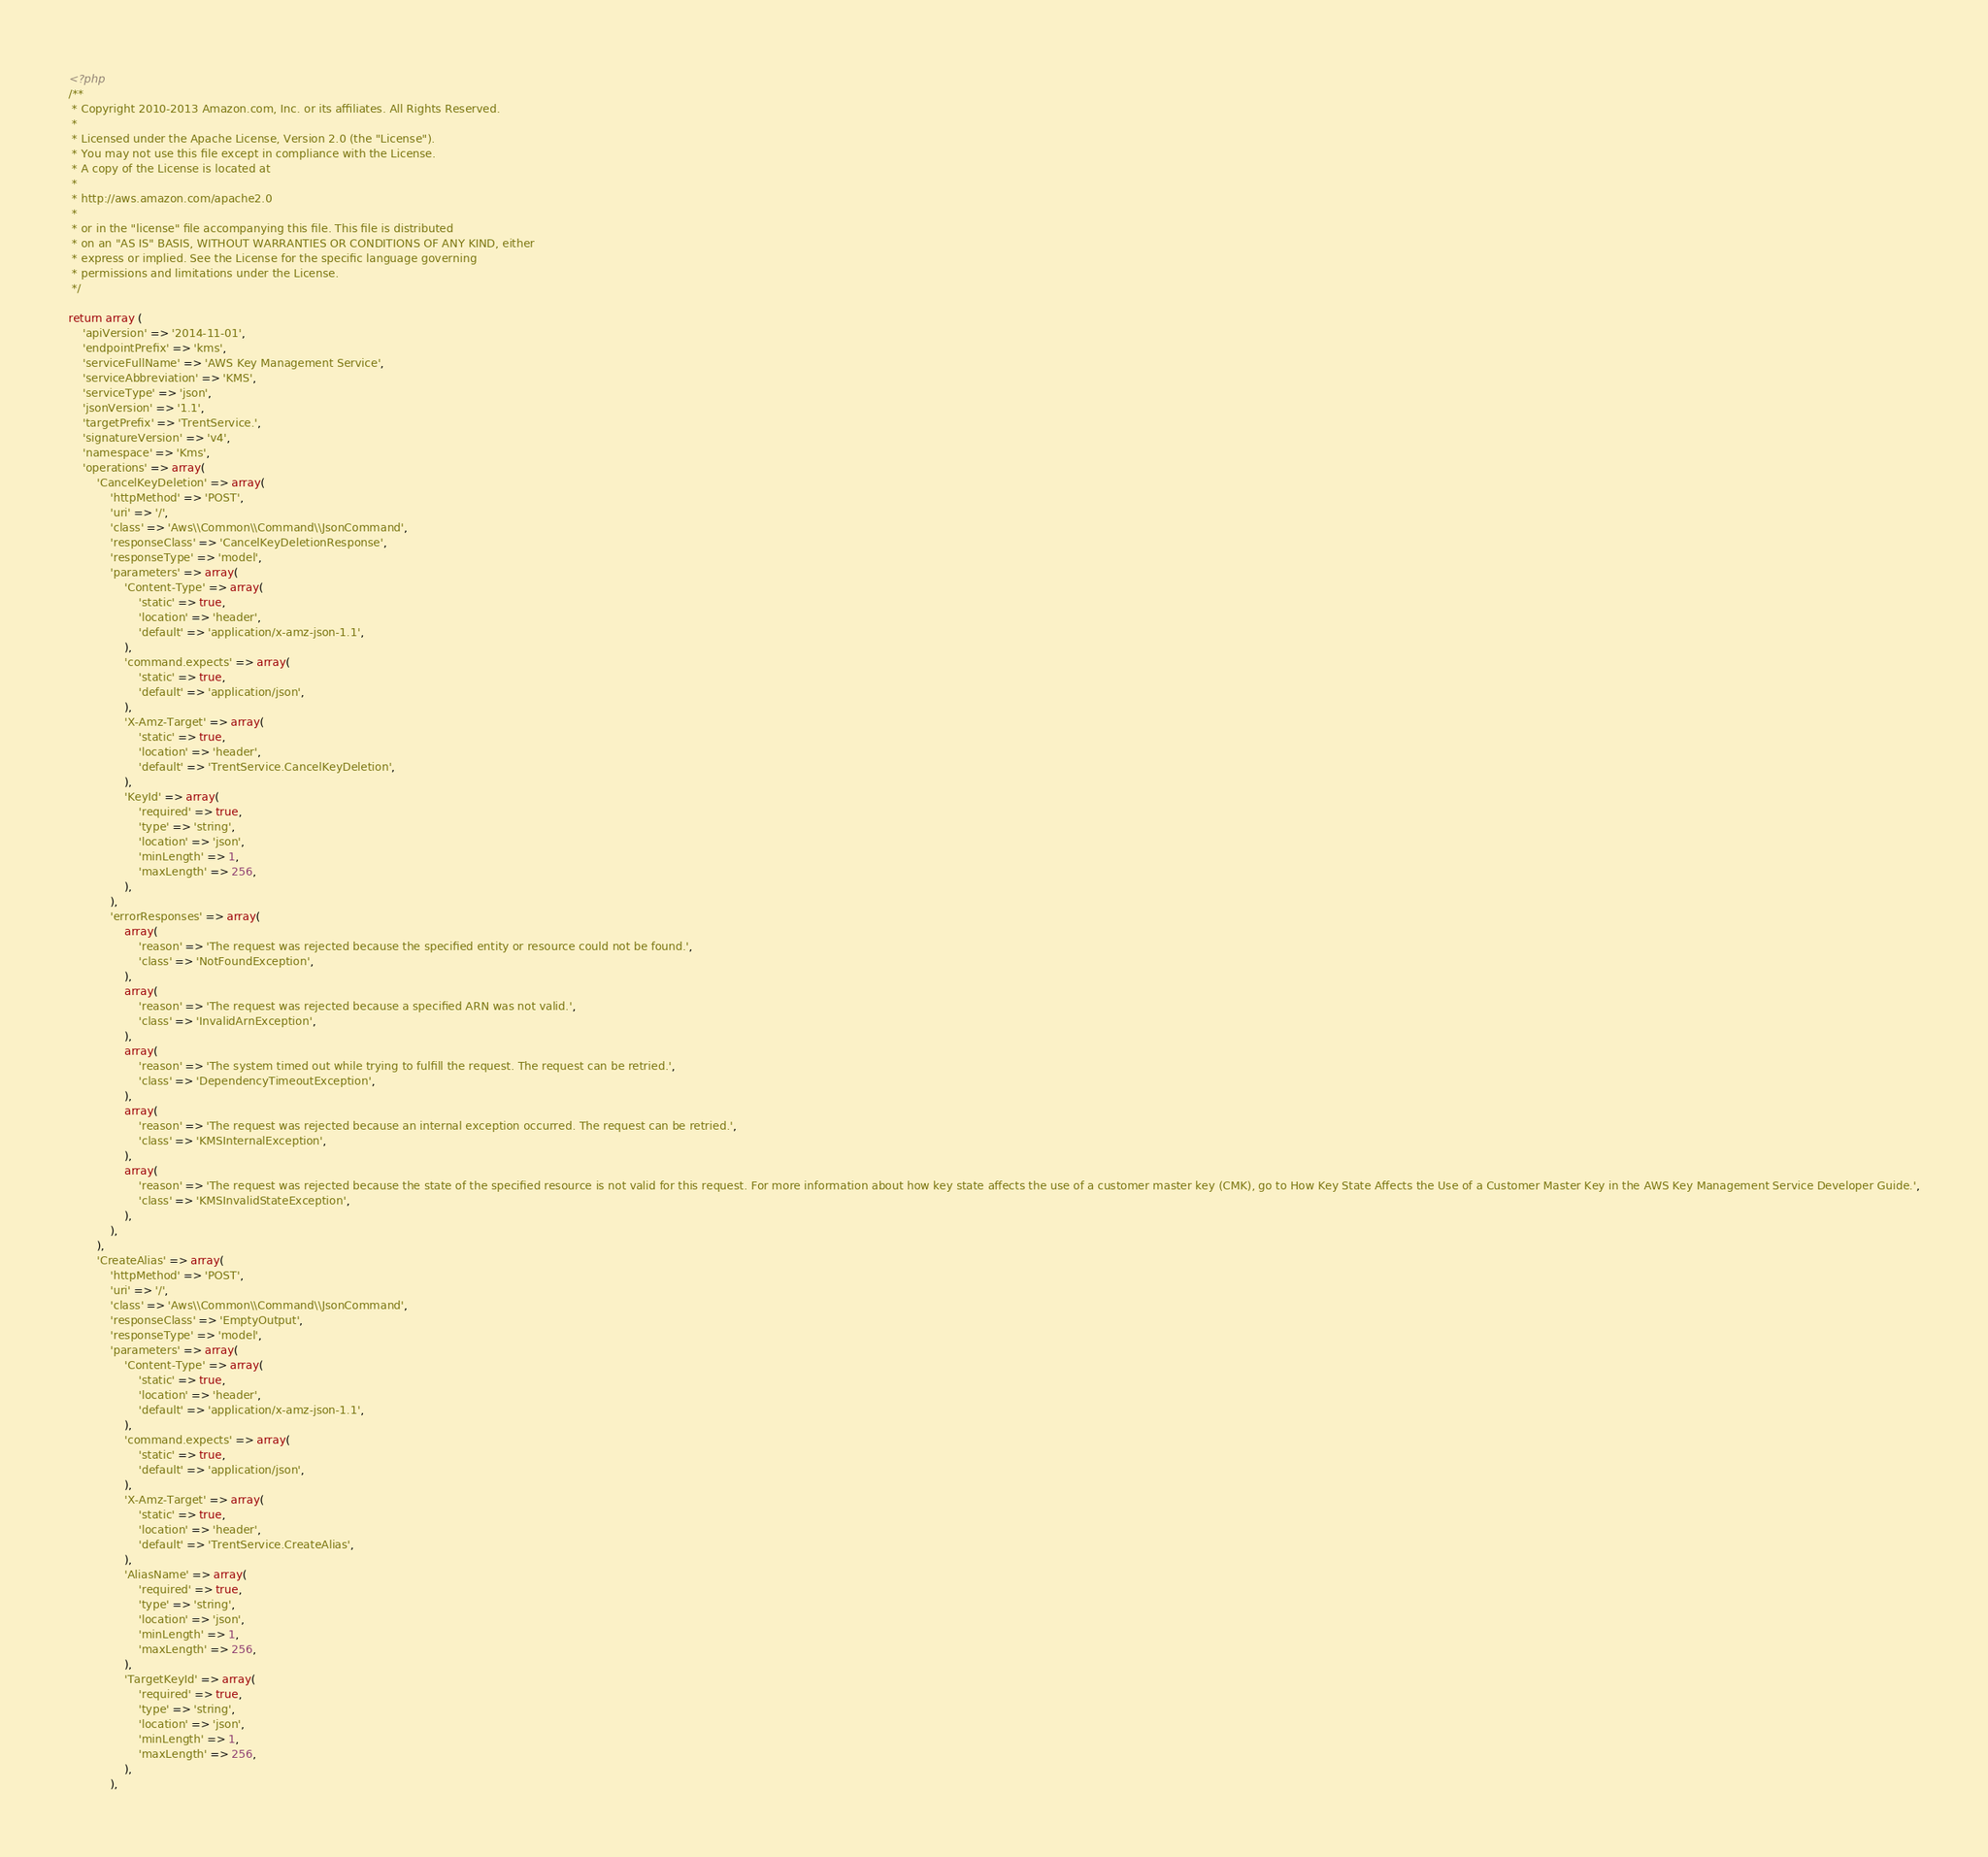<code> <loc_0><loc_0><loc_500><loc_500><_PHP_><?php
/**
 * Copyright 2010-2013 Amazon.com, Inc. or its affiliates. All Rights Reserved.
 *
 * Licensed under the Apache License, Version 2.0 (the "License").
 * You may not use this file except in compliance with the License.
 * A copy of the License is located at
 *
 * http://aws.amazon.com/apache2.0
 *
 * or in the "license" file accompanying this file. This file is distributed
 * on an "AS IS" BASIS, WITHOUT WARRANTIES OR CONDITIONS OF ANY KIND, either
 * express or implied. See the License for the specific language governing
 * permissions and limitations under the License.
 */

return array (
    'apiVersion' => '2014-11-01',
    'endpointPrefix' => 'kms',
    'serviceFullName' => 'AWS Key Management Service',
    'serviceAbbreviation' => 'KMS',
    'serviceType' => 'json',
    'jsonVersion' => '1.1',
    'targetPrefix' => 'TrentService.',
    'signatureVersion' => 'v4',
    'namespace' => 'Kms',
    'operations' => array(
        'CancelKeyDeletion' => array(
            'httpMethod' => 'POST',
            'uri' => '/',
            'class' => 'Aws\\Common\\Command\\JsonCommand',
            'responseClass' => 'CancelKeyDeletionResponse',
            'responseType' => 'model',
            'parameters' => array(
                'Content-Type' => array(
                    'static' => true,
                    'location' => 'header',
                    'default' => 'application/x-amz-json-1.1',
                ),
                'command.expects' => array(
                    'static' => true,
                    'default' => 'application/json',
                ),
                'X-Amz-Target' => array(
                    'static' => true,
                    'location' => 'header',
                    'default' => 'TrentService.CancelKeyDeletion',
                ),
                'KeyId' => array(
                    'required' => true,
                    'type' => 'string',
                    'location' => 'json',
                    'minLength' => 1,
                    'maxLength' => 256,
                ),
            ),
            'errorResponses' => array(
                array(
                    'reason' => 'The request was rejected because the specified entity or resource could not be found.',
                    'class' => 'NotFoundException',
                ),
                array(
                    'reason' => 'The request was rejected because a specified ARN was not valid.',
                    'class' => 'InvalidArnException',
                ),
                array(
                    'reason' => 'The system timed out while trying to fulfill the request. The request can be retried.',
                    'class' => 'DependencyTimeoutException',
                ),
                array(
                    'reason' => 'The request was rejected because an internal exception occurred. The request can be retried.',
                    'class' => 'KMSInternalException',
                ),
                array(
                    'reason' => 'The request was rejected because the state of the specified resource is not valid for this request. For more information about how key state affects the use of a customer master key (CMK), go to How Key State Affects the Use of a Customer Master Key in the AWS Key Management Service Developer Guide.',
                    'class' => 'KMSInvalidStateException',
                ),
            ),
        ),
        'CreateAlias' => array(
            'httpMethod' => 'POST',
            'uri' => '/',
            'class' => 'Aws\\Common\\Command\\JsonCommand',
            'responseClass' => 'EmptyOutput',
            'responseType' => 'model',
            'parameters' => array(
                'Content-Type' => array(
                    'static' => true,
                    'location' => 'header',
                    'default' => 'application/x-amz-json-1.1',
                ),
                'command.expects' => array(
                    'static' => true,
                    'default' => 'application/json',
                ),
                'X-Amz-Target' => array(
                    'static' => true,
                    'location' => 'header',
                    'default' => 'TrentService.CreateAlias',
                ),
                'AliasName' => array(
                    'required' => true,
                    'type' => 'string',
                    'location' => 'json',
                    'minLength' => 1,
                    'maxLength' => 256,
                ),
                'TargetKeyId' => array(
                    'required' => true,
                    'type' => 'string',
                    'location' => 'json',
                    'minLength' => 1,
                    'maxLength' => 256,
                ),
            ),</code> 